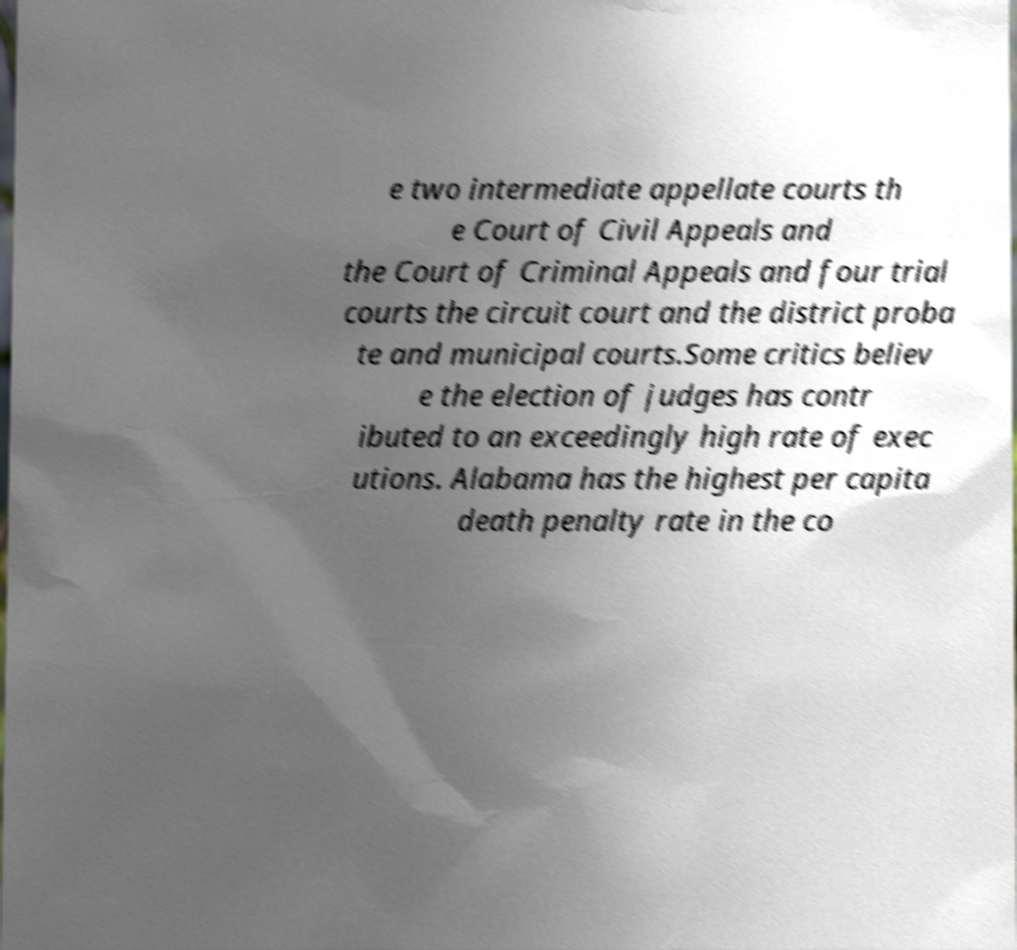Please identify and transcribe the text found in this image. e two intermediate appellate courts th e Court of Civil Appeals and the Court of Criminal Appeals and four trial courts the circuit court and the district proba te and municipal courts.Some critics believ e the election of judges has contr ibuted to an exceedingly high rate of exec utions. Alabama has the highest per capita death penalty rate in the co 